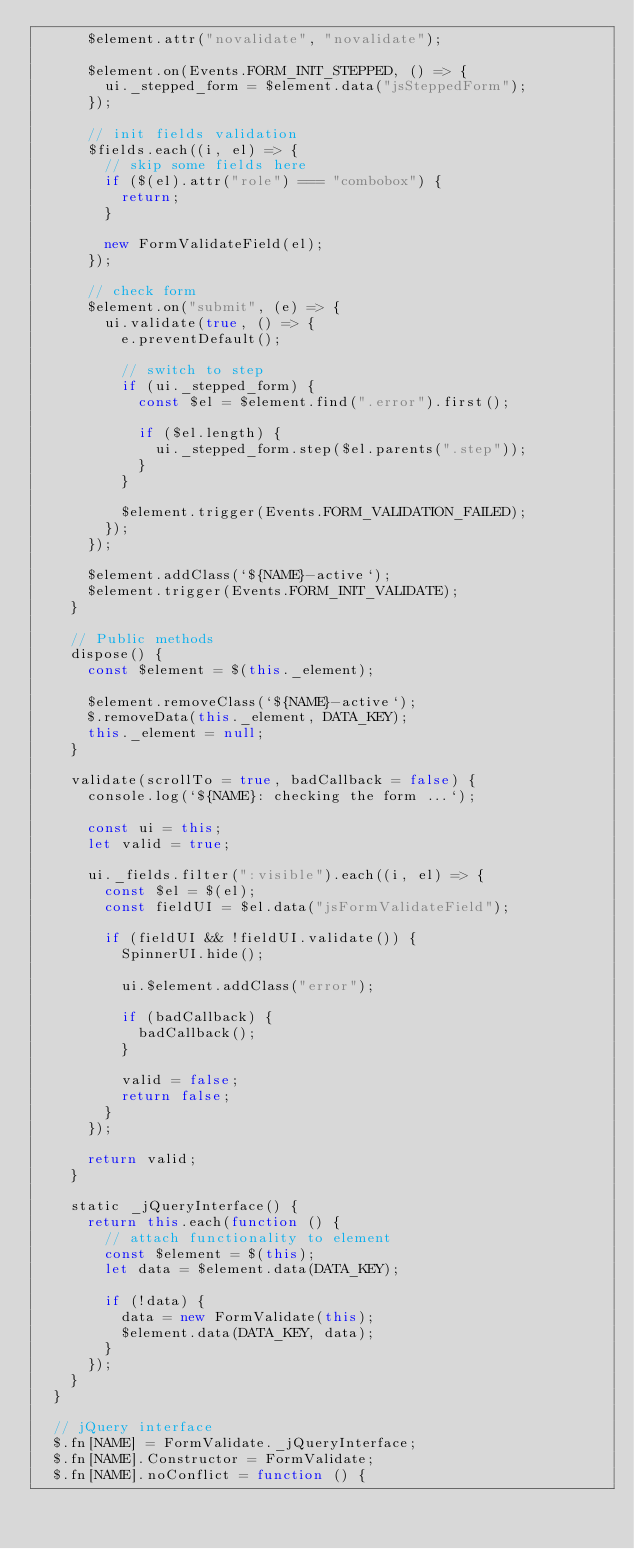Convert code to text. <code><loc_0><loc_0><loc_500><loc_500><_JavaScript_>      $element.attr("novalidate", "novalidate");

      $element.on(Events.FORM_INIT_STEPPED, () => {
        ui._stepped_form = $element.data("jsSteppedForm");
      });

      // init fields validation
      $fields.each((i, el) => {
        // skip some fields here
        if ($(el).attr("role") === "combobox") {
          return;
        }

        new FormValidateField(el);
      });

      // check form
      $element.on("submit", (e) => {
        ui.validate(true, () => {
          e.preventDefault();

          // switch to step
          if (ui._stepped_form) {
            const $el = $element.find(".error").first();

            if ($el.length) {
              ui._stepped_form.step($el.parents(".step"));
            }
          }

          $element.trigger(Events.FORM_VALIDATION_FAILED);
        });
      });

      $element.addClass(`${NAME}-active`);
      $element.trigger(Events.FORM_INIT_VALIDATE);
    }

    // Public methods
    dispose() {
      const $element = $(this._element);

      $element.removeClass(`${NAME}-active`);
      $.removeData(this._element, DATA_KEY);
      this._element = null;
    }

    validate(scrollTo = true, badCallback = false) {
      console.log(`${NAME}: checking the form ...`);

      const ui = this;
      let valid = true;

      ui._fields.filter(":visible").each((i, el) => {
        const $el = $(el);
        const fieldUI = $el.data("jsFormValidateField");

        if (fieldUI && !fieldUI.validate()) {
          SpinnerUI.hide();

          ui.$element.addClass("error");

          if (badCallback) {
            badCallback();
          }

          valid = false;
          return false;
        }
      });

      return valid;
    }

    static _jQueryInterface() {
      return this.each(function () {
        // attach functionality to element
        const $element = $(this);
        let data = $element.data(DATA_KEY);

        if (!data) {
          data = new FormValidate(this);
          $element.data(DATA_KEY, data);
        }
      });
    }
  }

  // jQuery interface
  $.fn[NAME] = FormValidate._jQueryInterface;
  $.fn[NAME].Constructor = FormValidate;
  $.fn[NAME].noConflict = function () {</code> 